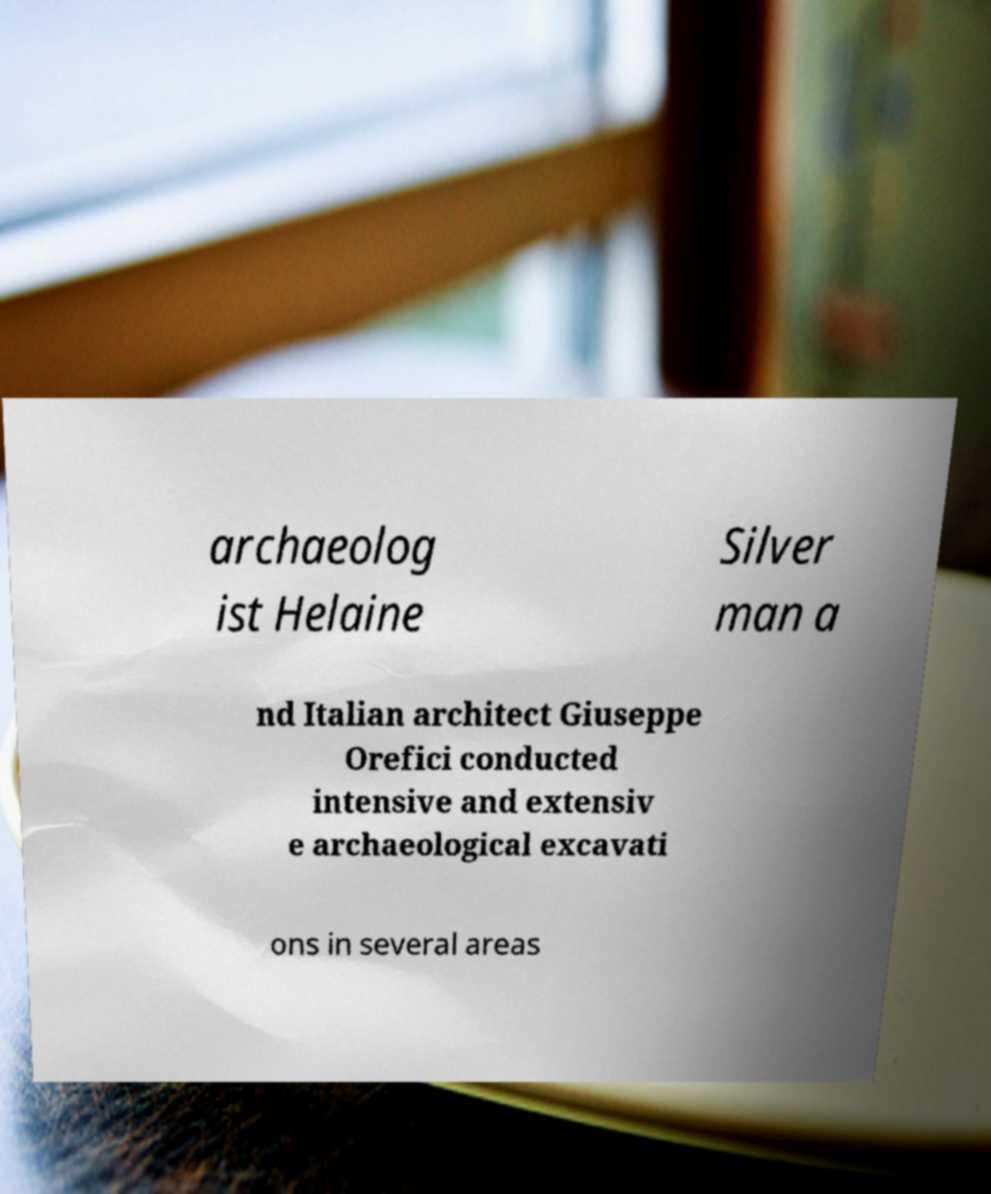Can you accurately transcribe the text from the provided image for me? archaeolog ist Helaine Silver man a nd Italian architect Giuseppe Orefici conducted intensive and extensiv e archaeological excavati ons in several areas 